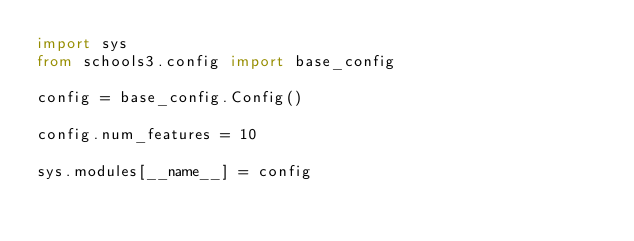Convert code to text. <code><loc_0><loc_0><loc_500><loc_500><_Python_>import sys
from schools3.config import base_config

config = base_config.Config()

config.num_features = 10

sys.modules[__name__] = config
</code> 